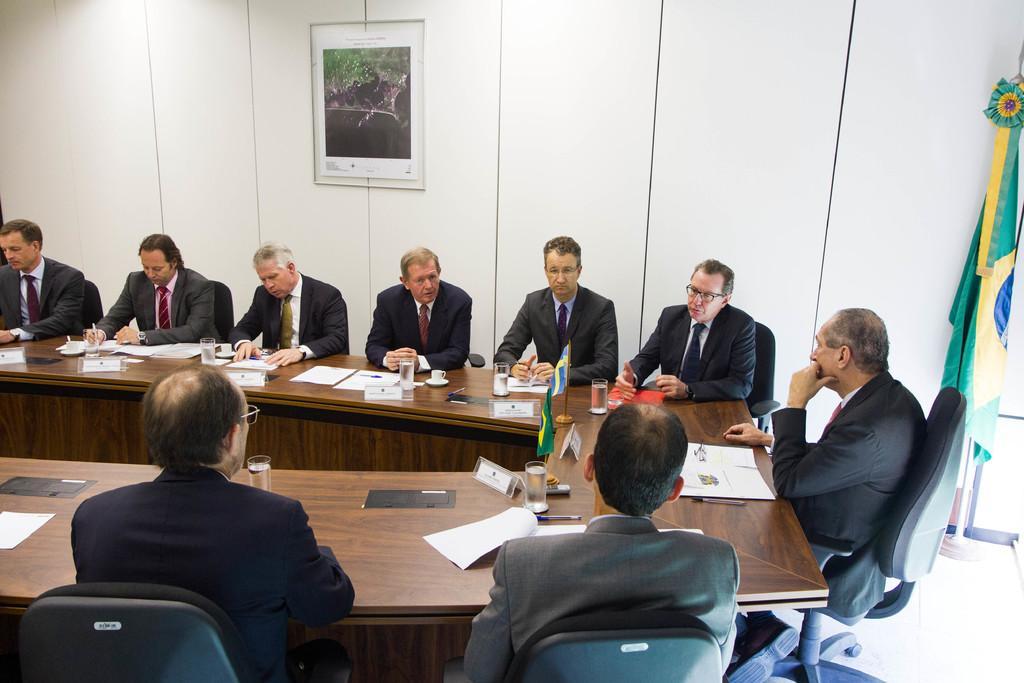How would you summarize this image in a sentence or two? There are group of persons wearing suits and seating in front of a table which has some papers,glass of water and two flags on it. 